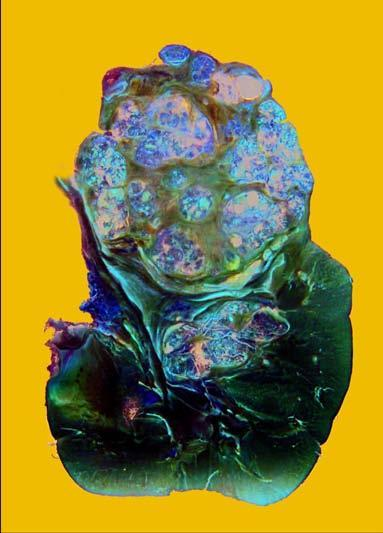does sectioned surface show irregular, circumscribed, yellowish mass with areas of haemorrhages and necrosis?
Answer the question using a single word or phrase. Yes 